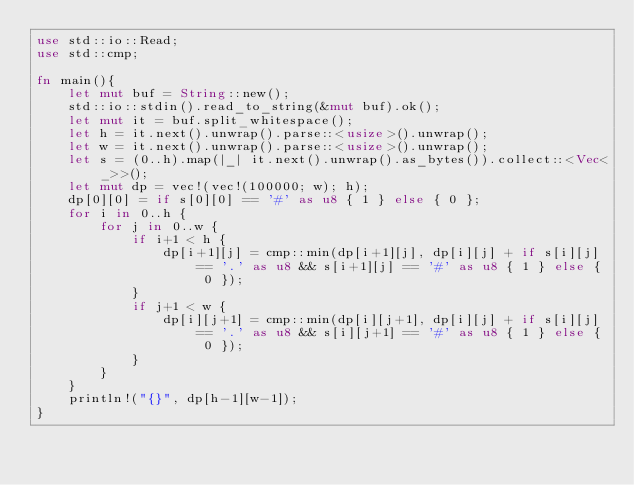Convert code to text. <code><loc_0><loc_0><loc_500><loc_500><_Rust_>use std::io::Read;
use std::cmp;

fn main(){
    let mut buf = String::new();
    std::io::stdin().read_to_string(&mut buf).ok();
    let mut it = buf.split_whitespace();
    let h = it.next().unwrap().parse::<usize>().unwrap();
    let w = it.next().unwrap().parse::<usize>().unwrap();
    let s = (0..h).map(|_| it.next().unwrap().as_bytes()).collect::<Vec<_>>();
    let mut dp = vec!(vec!(100000; w); h);
    dp[0][0] = if s[0][0] == '#' as u8 { 1 } else { 0 };
    for i in 0..h {
        for j in 0..w {
            if i+1 < h {
                dp[i+1][j] = cmp::min(dp[i+1][j], dp[i][j] + if s[i][j] == '.' as u8 && s[i+1][j] == '#' as u8 { 1 } else { 0 });
            }
            if j+1 < w {
                dp[i][j+1] = cmp::min(dp[i][j+1], dp[i][j] + if s[i][j] == '.' as u8 && s[i][j+1] == '#' as u8 { 1 } else { 0 });
            }
        }
    }
    println!("{}", dp[h-1][w-1]);
}</code> 